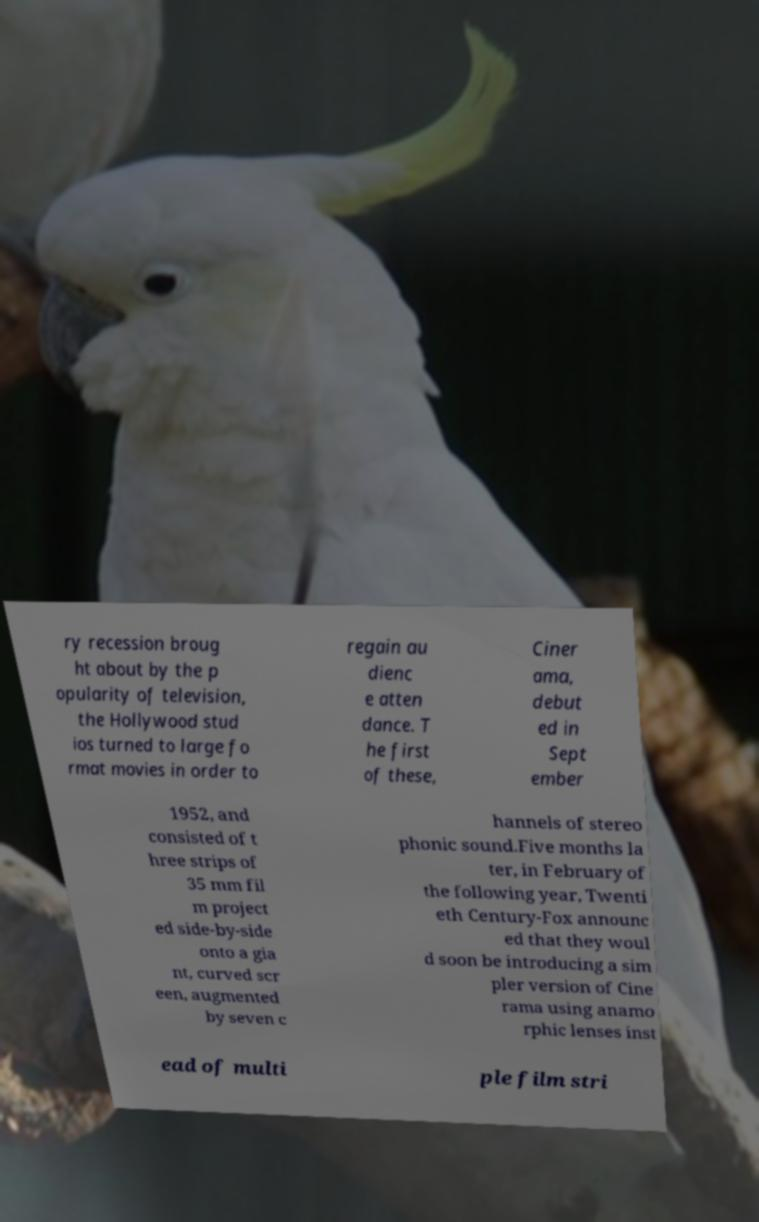What messages or text are displayed in this image? I need them in a readable, typed format. ry recession broug ht about by the p opularity of television, the Hollywood stud ios turned to large fo rmat movies in order to regain au dienc e atten dance. T he first of these, Ciner ama, debut ed in Sept ember 1952, and consisted of t hree strips of 35 mm fil m project ed side-by-side onto a gia nt, curved scr een, augmented by seven c hannels of stereo phonic sound.Five months la ter, in February of the following year, Twenti eth Century-Fox announc ed that they woul d soon be introducing a sim pler version of Cine rama using anamo rphic lenses inst ead of multi ple film stri 